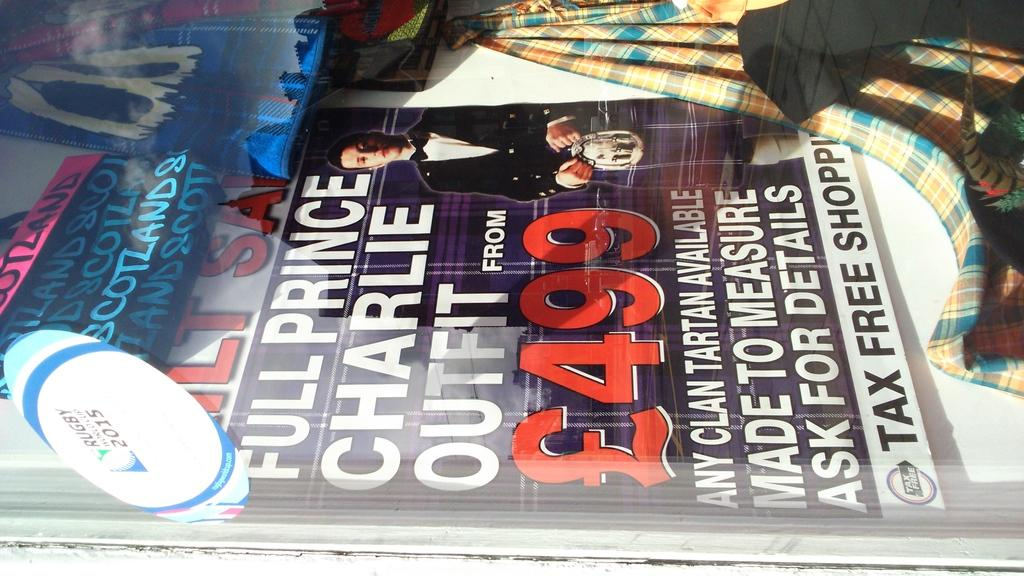<image>
Share a concise interpretation of the image provided. Cover of a magazine under a glass that says 499. 